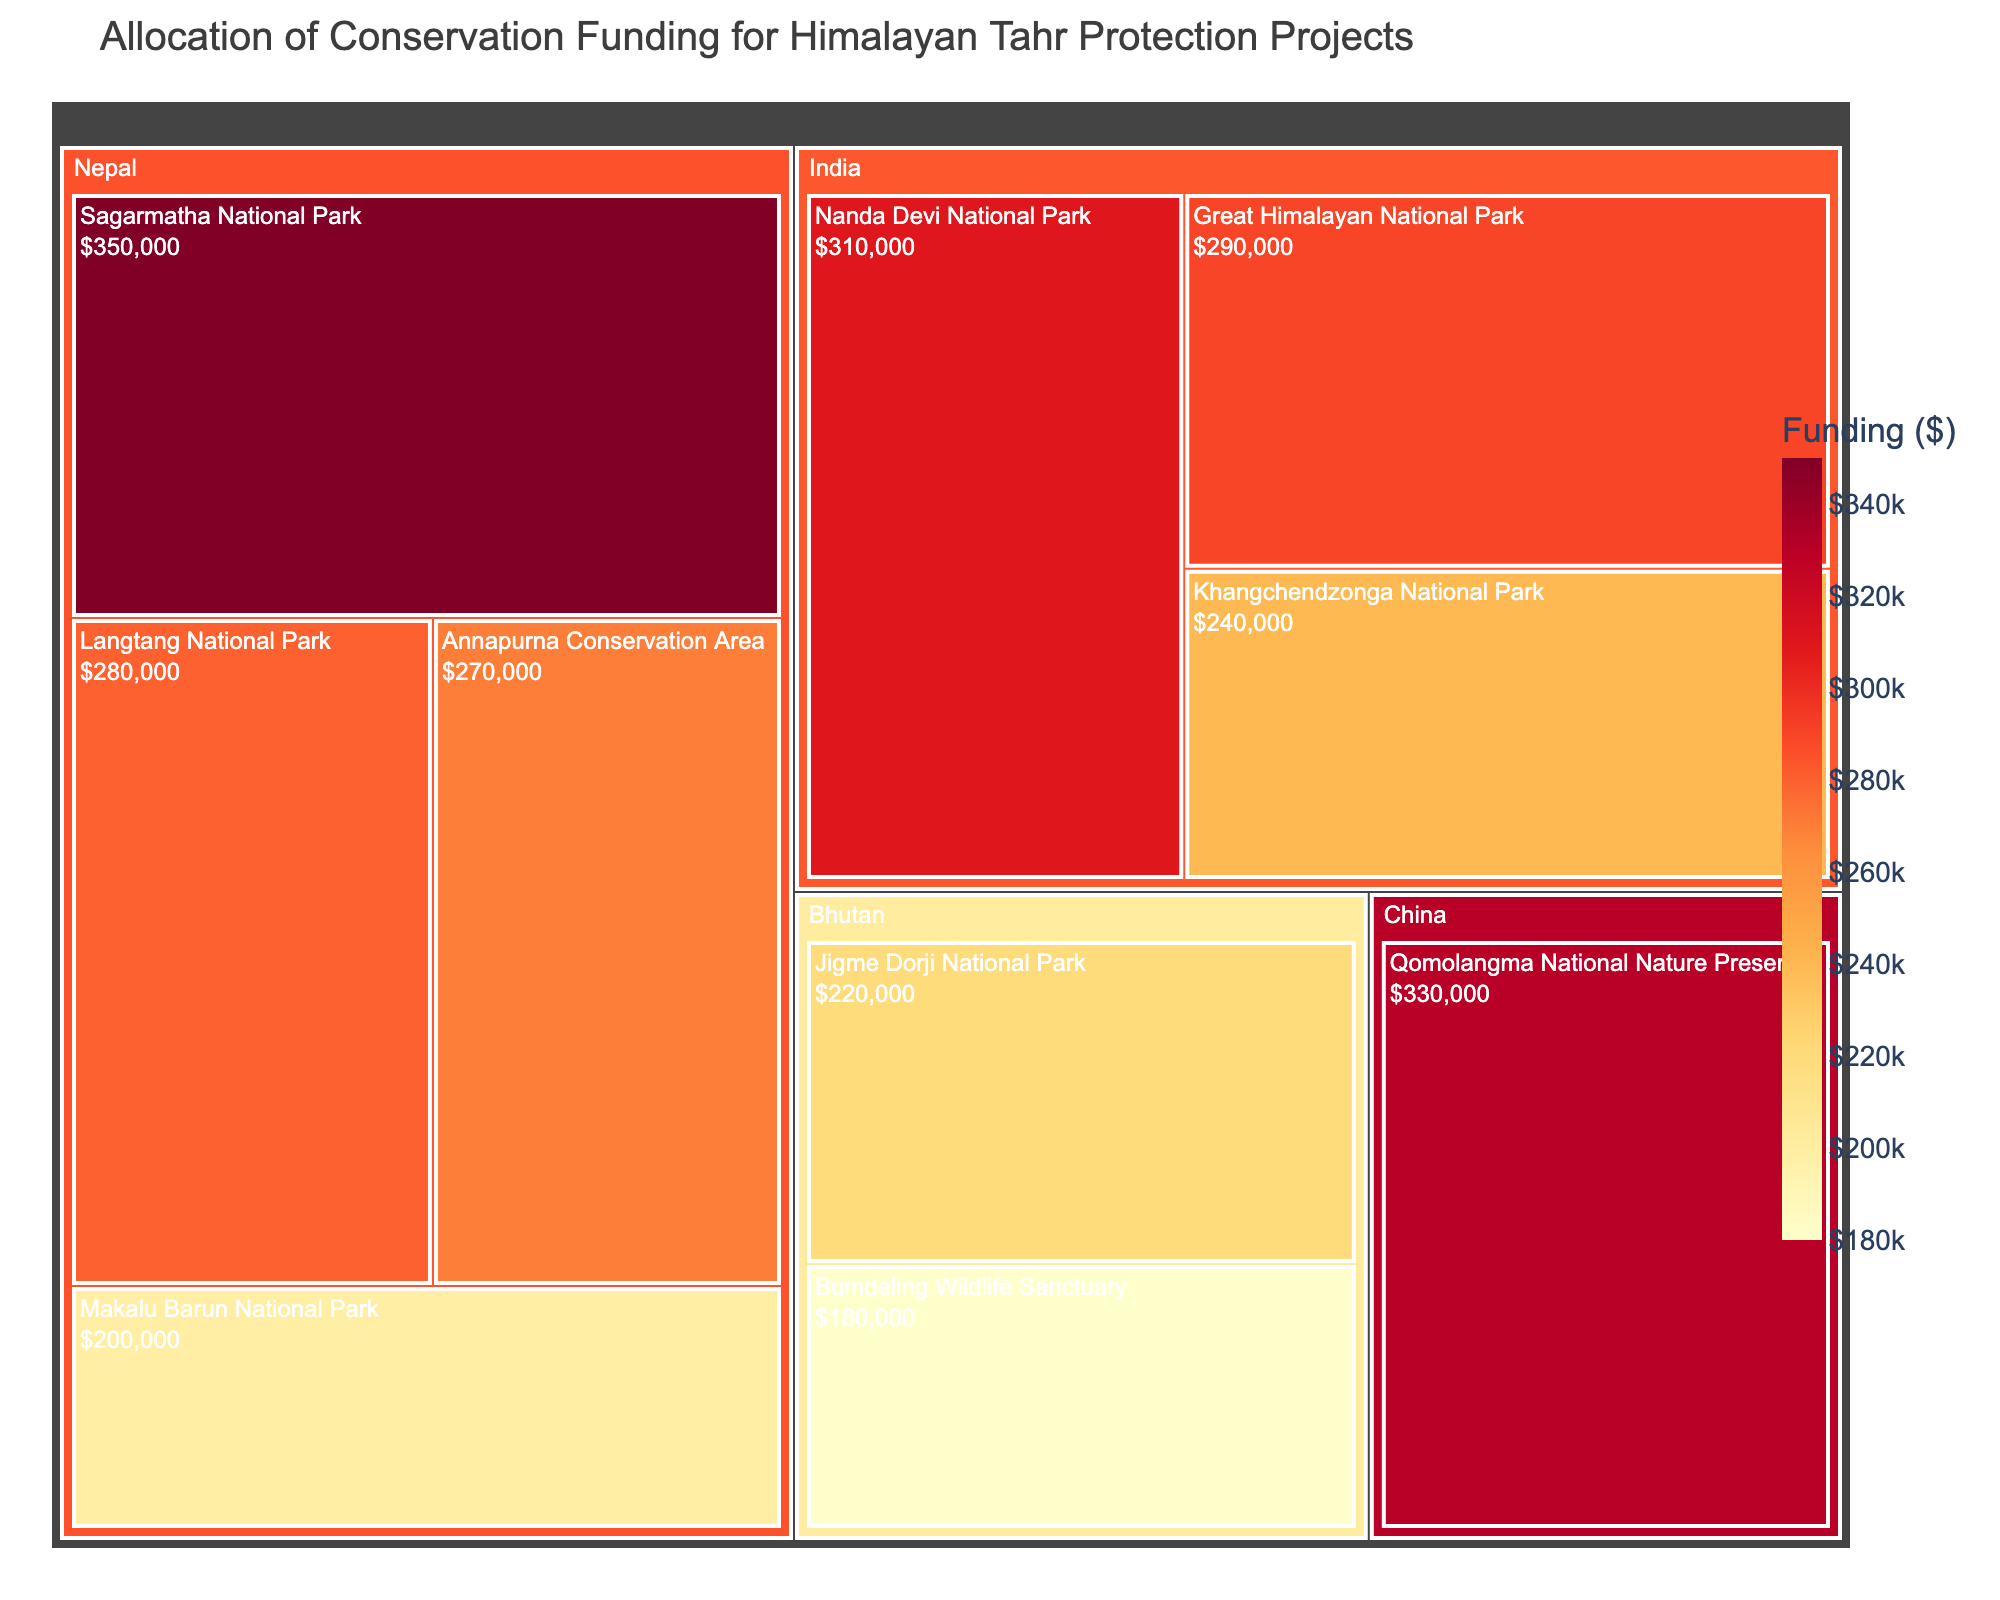Which region has the highest allocation of conservation funding? By observing the treemap, we look for the region with the largest box or the darkest color. The largest and darkest colored box belongs to 'Nepal' with the highest allocation for Sagarmatha National Park.
Answer: Nepal Which area in India received the most funding? From the treemap under the India region, we compare the funding values labelled in the boxes. 'Nanda Devi National Park' has the highest funding.
Answer: Nanda Devi National Park What is the total funding allocated to projects in Nepal? Sum the funding of all areas in Nepal: Sagarmatha National Park ($350,000), Langtang National Park ($280,000), Annapurna Conservation Area ($270,000), and Makalu Barun National Park ($200,000). The total is $350,000 + $280,000 + $270,000 + $200,000.
Answer: $1,100,000 Which region has more conservation funding, Bhutan or China? Compare the total funding for areas in Bhutan and China. Bhutan has $220,000 (Jigme Dorji National Park) + $180,000 (Bumdeling Wildlife Sanctuary) = $400,000. China has $330,000 (Qomolangma National Nature Preserve). Therefore, Bhutan has more funding.
Answer: Bhutan Which area received the least funding? Identify the smallest box or lightest color in the treemap. 'Bumdeling Wildlife Sanctuary' in Bhutan received the least funding.
Answer: Bumdeling Wildlife Sanctuary What is the average funding allocated to the areas in India? Sum the funding of all areas in India and divide by the number of areas. Total funding = $310,000 (Nanda Devi National Park) + $290,000 (Great Himalayan National Park) + $240,000 (Khangchendzonga National Park) = $840,000. Number of areas = 3. Average funding = $840,000 / 3.
Answer: $280,000 Which region has the highest number of conservation areas funded? Count the number of distinct areas for each region in the treemap. Nepal has the most areas funded with 4 distinct areas.
Answer: Nepal How does the funding for Langtang National Park compare to that of Khangchendzonga National Park? Compare the funding amounts directly from the treemap. Langtang National Park has $280,000 and Khangchendzonga National Park has $240,000. Langtang National Park received more funding.
Answer: Langtang National Park What is the funding difference between the highest and lowest funded areas? Identify the highest and lowest funding amounts in the treemap. The highest is Sagarmatha National Park ($350,000) and the lowest is Bumdeling Wildlife Sanctuary ($180,000). The difference is $350,000 - $180,000.
Answer: $170,000 